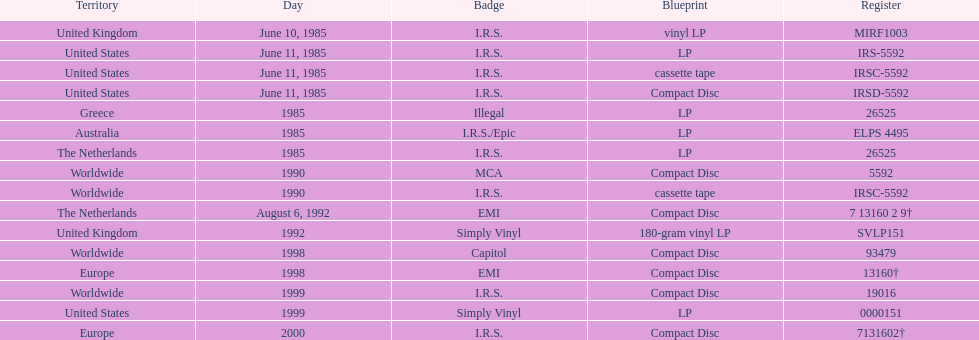What is the largest sequential quantity of releases in lp format? 3. 